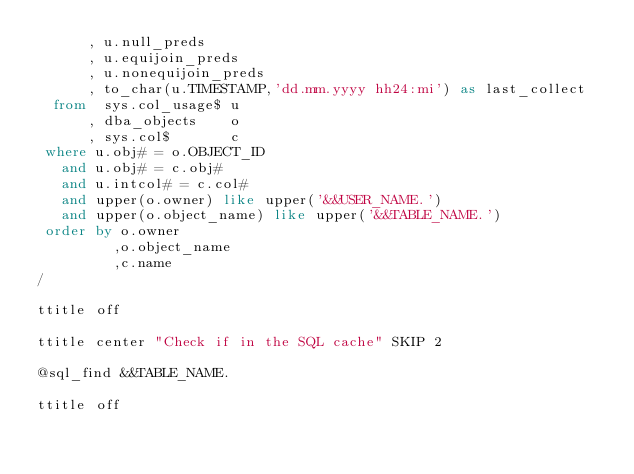<code> <loc_0><loc_0><loc_500><loc_500><_SQL_>      , u.null_preds
      , u.equijoin_preds
      , u.nonequijoin_preds
	  , to_char(u.TIMESTAMP,'dd.mm.yyyy hh24:mi') as last_collect
  from  sys.col_usage$ u
      , dba_objects    o
      , sys.col$       c
 where u.obj# = o.OBJECT_ID
   and u.obj# = c.obj#
   and u.intcol# = c.col#
   and upper(o.owner) like upper('&&USER_NAME.')
   and upper(o.object_name) like upper('&&TABLE_NAME.')
 order by o.owner
         ,o.object_name
         ,c.name
/  

ttitle off

ttitle center "Check if in the SQL cache" SKIP 2

@sql_find &&TABLE_NAME.

ttitle off

</code> 